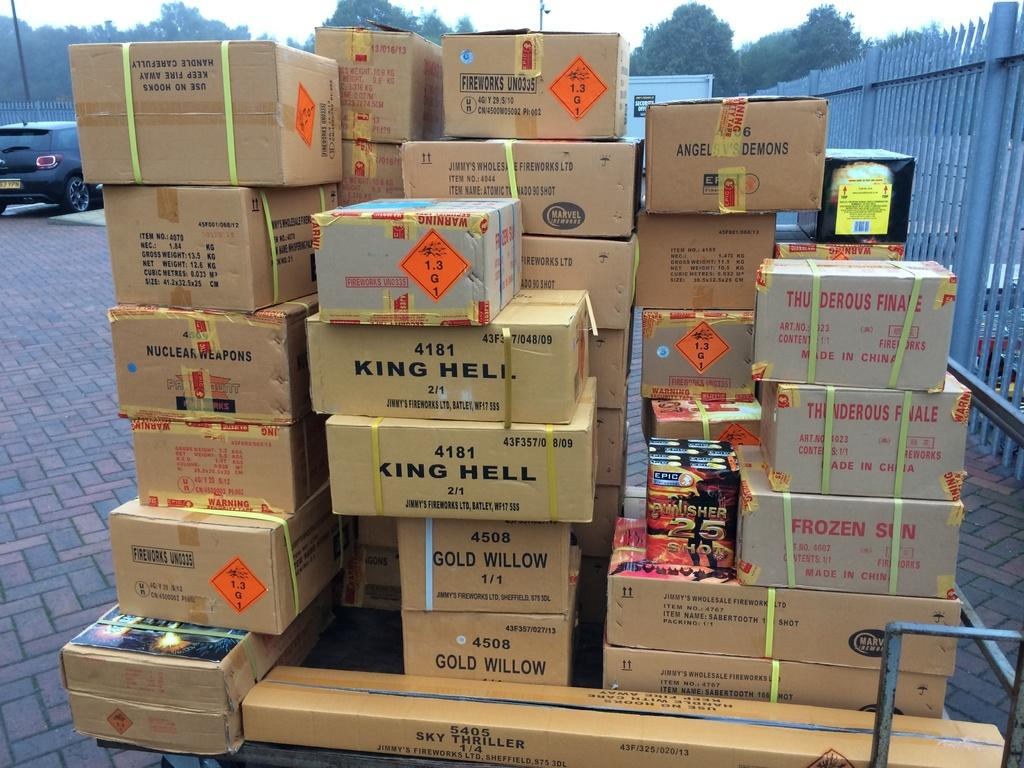<image>
Create a compact narrative representing the image presented. A pile of boxes outside they are from different companies but the one that stands out the most is King Hell company. 